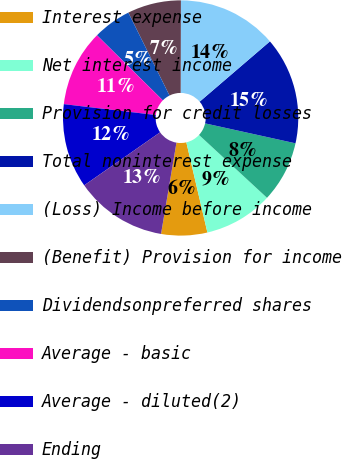Convert chart. <chart><loc_0><loc_0><loc_500><loc_500><pie_chart><fcel>Interest expense<fcel>Net interest income<fcel>Provision for credit losses<fcel>Total noninterest expense<fcel>(Loss) Income before income<fcel>(Benefit) Provision for income<fcel>Dividendsonpreferred shares<fcel>Average - basic<fcel>Average - diluted(2)<fcel>Ending<nl><fcel>6.32%<fcel>9.47%<fcel>8.42%<fcel>14.74%<fcel>13.68%<fcel>7.37%<fcel>5.26%<fcel>10.53%<fcel>11.58%<fcel>12.63%<nl></chart> 